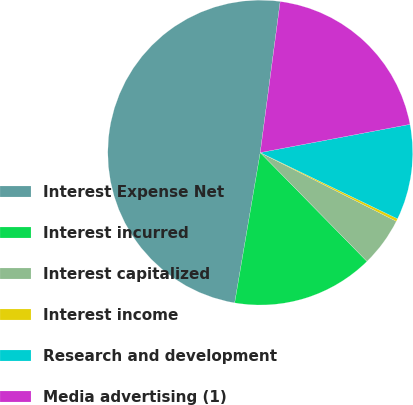Convert chart to OTSL. <chart><loc_0><loc_0><loc_500><loc_500><pie_chart><fcel>Interest Expense Net<fcel>Interest incurred<fcel>Interest capitalized<fcel>Interest income<fcel>Research and development<fcel>Media advertising (1)<nl><fcel>49.41%<fcel>15.03%<fcel>5.21%<fcel>0.29%<fcel>10.12%<fcel>19.94%<nl></chart> 